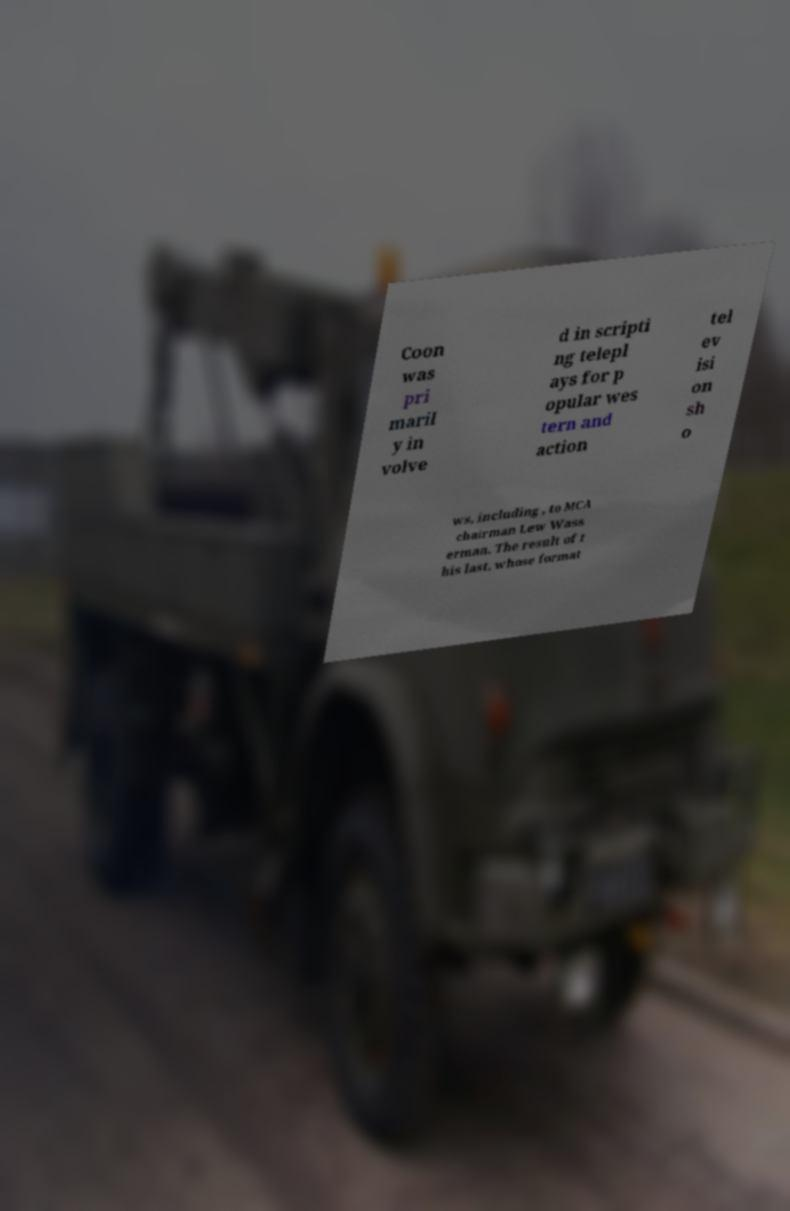I need the written content from this picture converted into text. Can you do that? Coon was pri maril y in volve d in scripti ng telepl ays for p opular wes tern and action tel ev isi on sh o ws, including , to MCA chairman Lew Wass erman. The result of t his last, whose format 